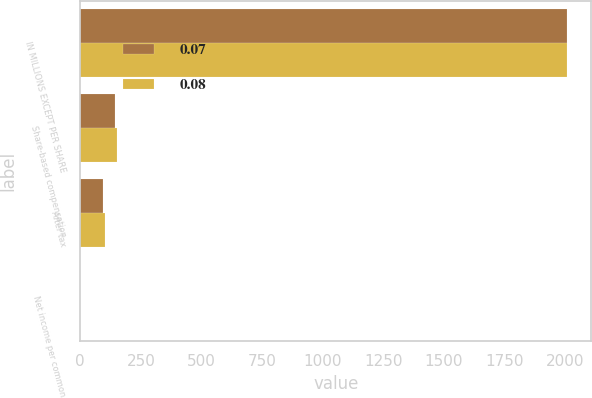<chart> <loc_0><loc_0><loc_500><loc_500><stacked_bar_chart><ecel><fcel>IN MILLIONS EXCEPT PER SHARE<fcel>Share-based compensation<fcel>After tax<fcel>Net income per common<nl><fcel>0.07<fcel>2007<fcel>142.4<fcel>94.9<fcel>0.07<nl><fcel>0.08<fcel>2005<fcel>152<fcel>102.3<fcel>0.08<nl></chart> 